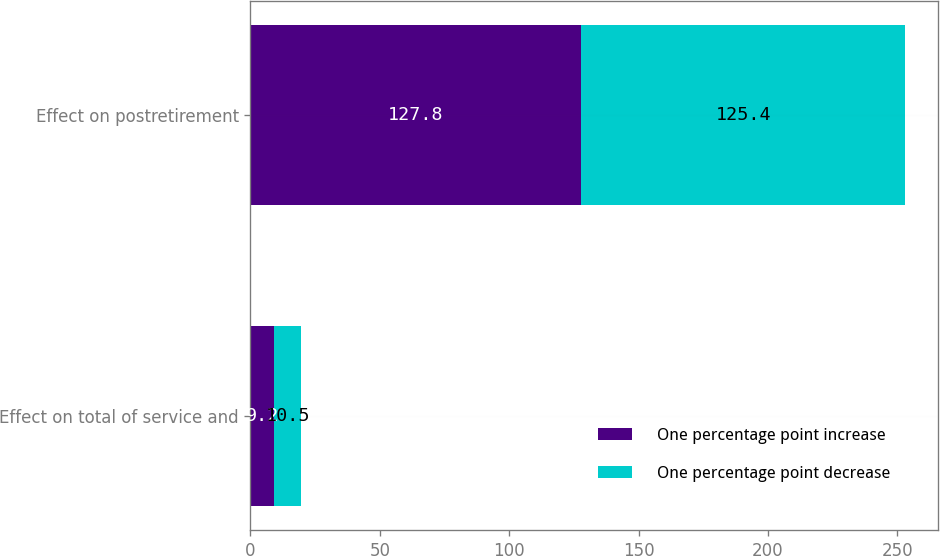Convert chart to OTSL. <chart><loc_0><loc_0><loc_500><loc_500><stacked_bar_chart><ecel><fcel>Effect on total of service and<fcel>Effect on postretirement<nl><fcel>One percentage point increase<fcel>9.2<fcel>127.8<nl><fcel>One percentage point decrease<fcel>10.5<fcel>125.4<nl></chart> 